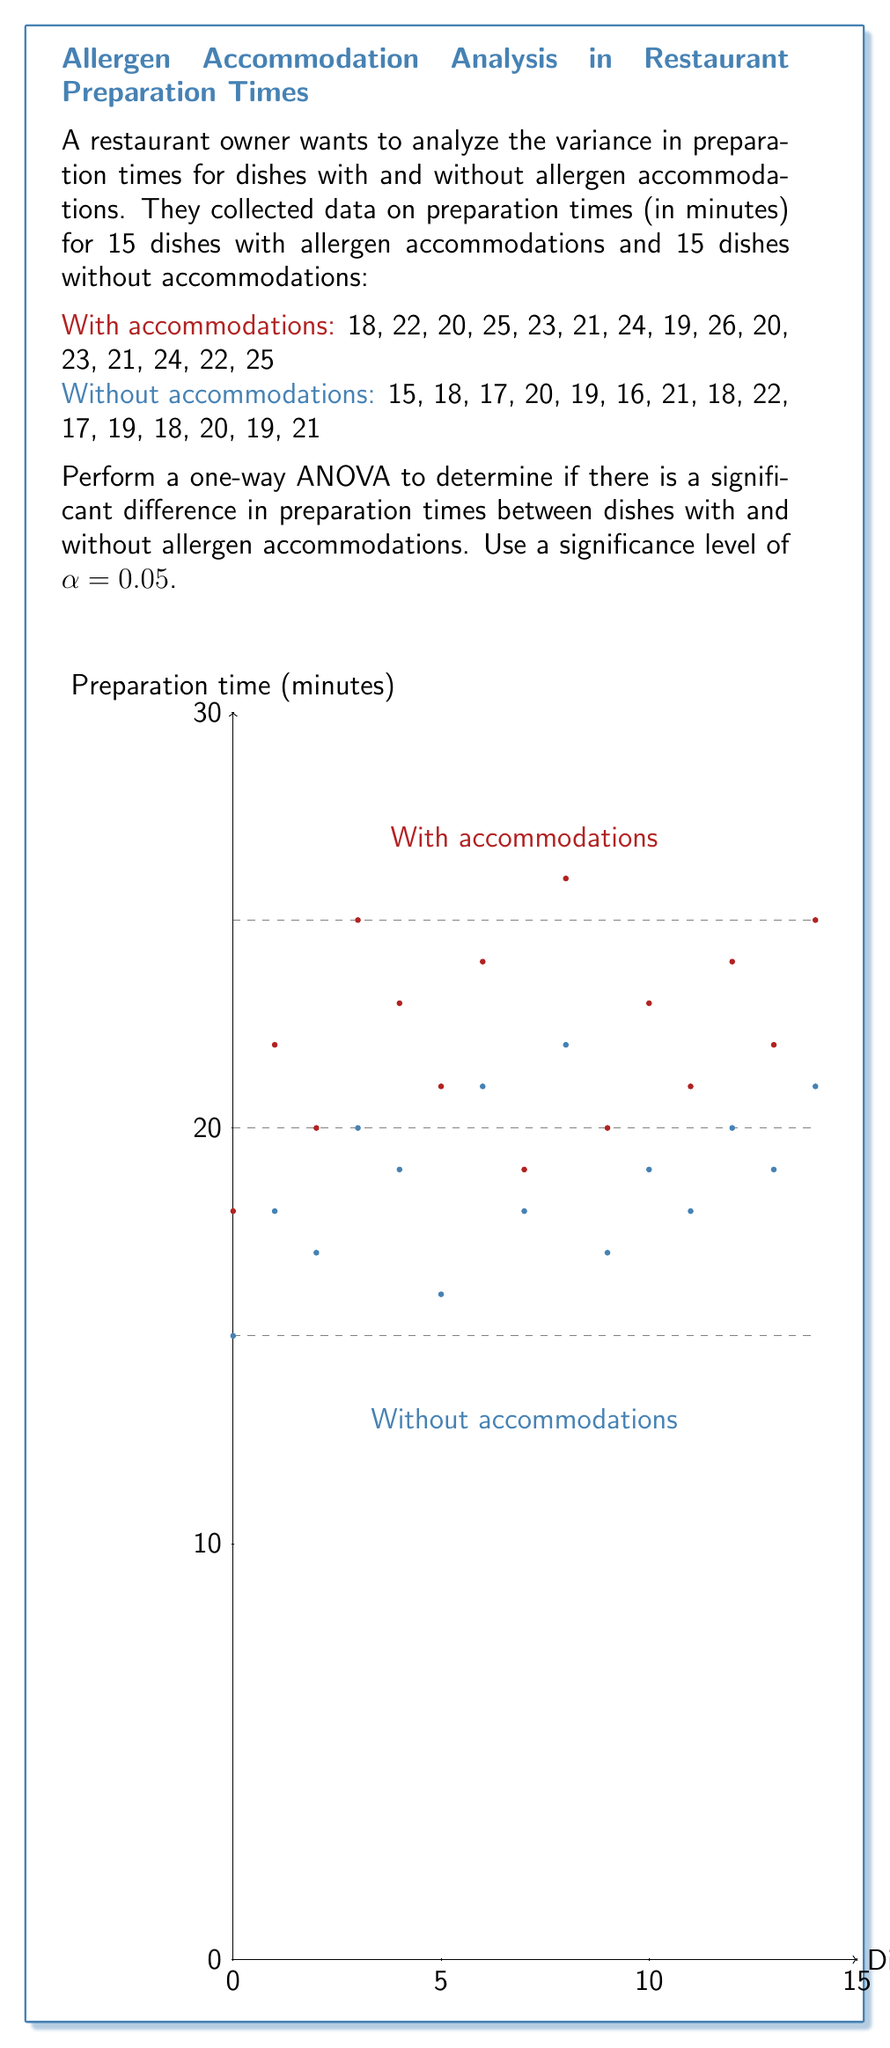What is the answer to this math problem? Let's perform a one-way ANOVA step-by-step:

1. Calculate the means for each group:
   $$\bar{X}_{\text{with}} = \frac{333}{15} = 22.2$$
   $$\bar{X}_{\text{without}} = \frac{280}{15} = 18.67$$

2. Calculate the overall mean:
   $$\bar{X}_{\text{total}} = \frac{333 + 280}{30} = 20.43$$

3. Calculate the Sum of Squares Between (SSB):
   $$SSB = 15(22.2 - 20.43)^2 + 15(18.67 - 20.43)^2 = 94.53$$

4. Calculate the Sum of Squares Within (SSW):
   $$SSW_{\text{with}} = \sum_{i=1}^{15} (X_i - 22.2)^2 = 77.8$$
   $$SSW_{\text{without}} = \sum_{i=1}^{15} (X_i - 18.67)^2 = 62.93$$
   $$SSW = 77.8 + 62.93 = 140.73$$

5. Calculate the Sum of Squares Total (SST):
   $$SST = SSB + SSW = 94.53 + 140.73 = 235.26$$

6. Calculate the degrees of freedom:
   $$df_{\text{between}} = 2 - 1 = 1$$
   $$df_{\text{within}} = 30 - 2 = 28$$
   $$df_{\text{total}} = 30 - 1 = 29$$

7. Calculate the Mean Square Between (MSB) and Mean Square Within (MSW):
   $$MSB = \frac{SSB}{df_{\text{between}}} = \frac{94.53}{1} = 94.53$$
   $$MSW = \frac{SSW}{df_{\text{within}}} = \frac{140.73}{28} = 5.03$$

8. Calculate the F-statistic:
   $$F = \frac{MSB}{MSW} = \frac{94.53}{5.03} = 18.79$$

9. Find the critical F-value:
   For α = 0.05, df_between = 1, and df_within = 28, the critical F-value is approximately 4.20.

10. Compare the F-statistic to the critical F-value:
    Since 18.79 > 4.20, we reject the null hypothesis.

11. Calculate the p-value:
    Using an F-distribution calculator, we find that p < 0.001.
Answer: F(1,28) = 18.79, p < 0.001. Significant difference in preparation times. 